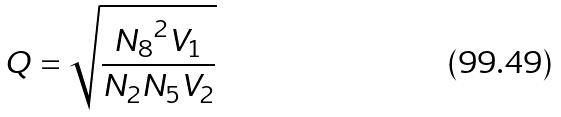<formula> <loc_0><loc_0><loc_500><loc_500>Q = \sqrt { \frac { { N _ { 8 } } ^ { 2 } V _ { 1 } } { N _ { 2 } N _ { 5 } V _ { 2 } } }</formula> 